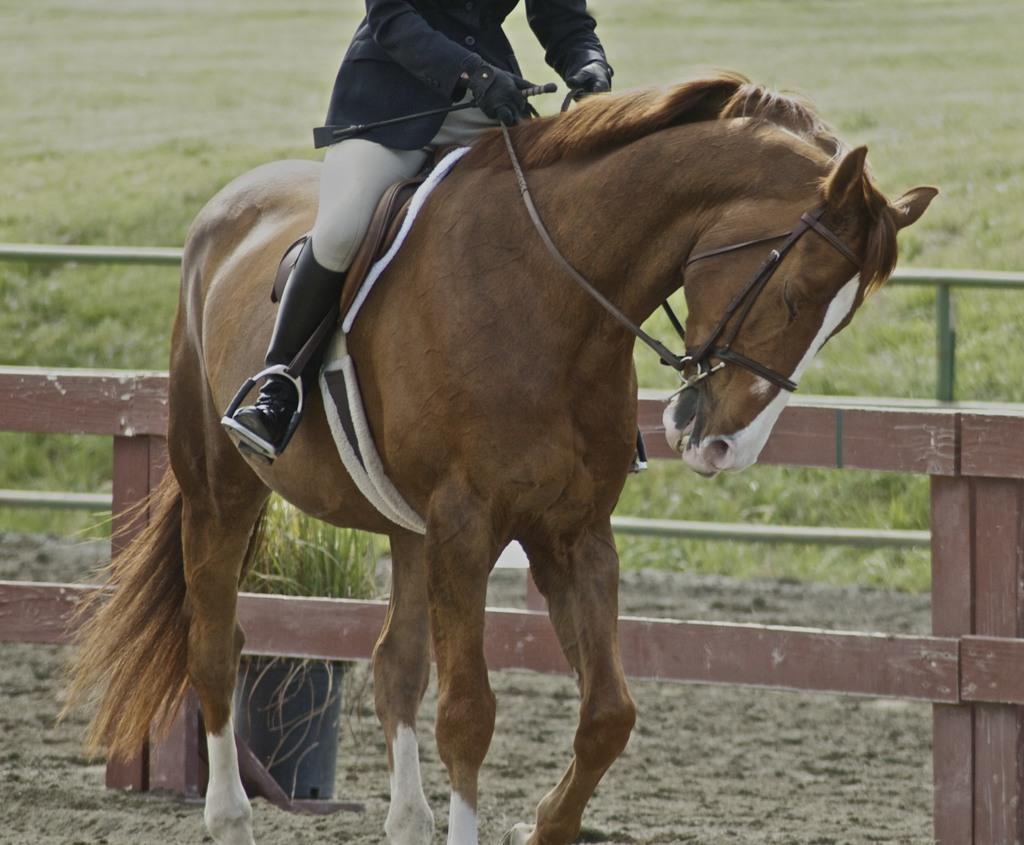What is the person in the image doing? The person is sitting on a horse in the image. What is at the bottom of the image? There is ground at the bottom of the image. What can be seen in the background of the image? There is a plant with a pot, wooden fencing, rods, and grass visible in the background of the image. What type of substance can be seen dripping from the horse's mouth in the image? There is no substance dripping from the horse's mouth in the image. What sound can be heard coming from the plant with a pot in the background of the image? There is no sound coming from the plant with a pot in the image, as plants do not produce sound. 